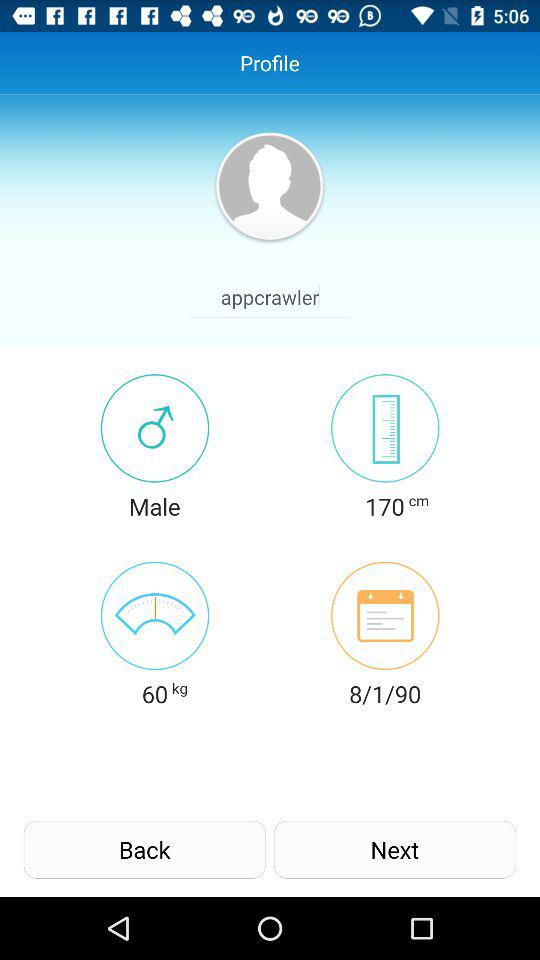What is the user's height in feet and inches?
When the provided information is insufficient, respond with <no answer>. <no answer> 